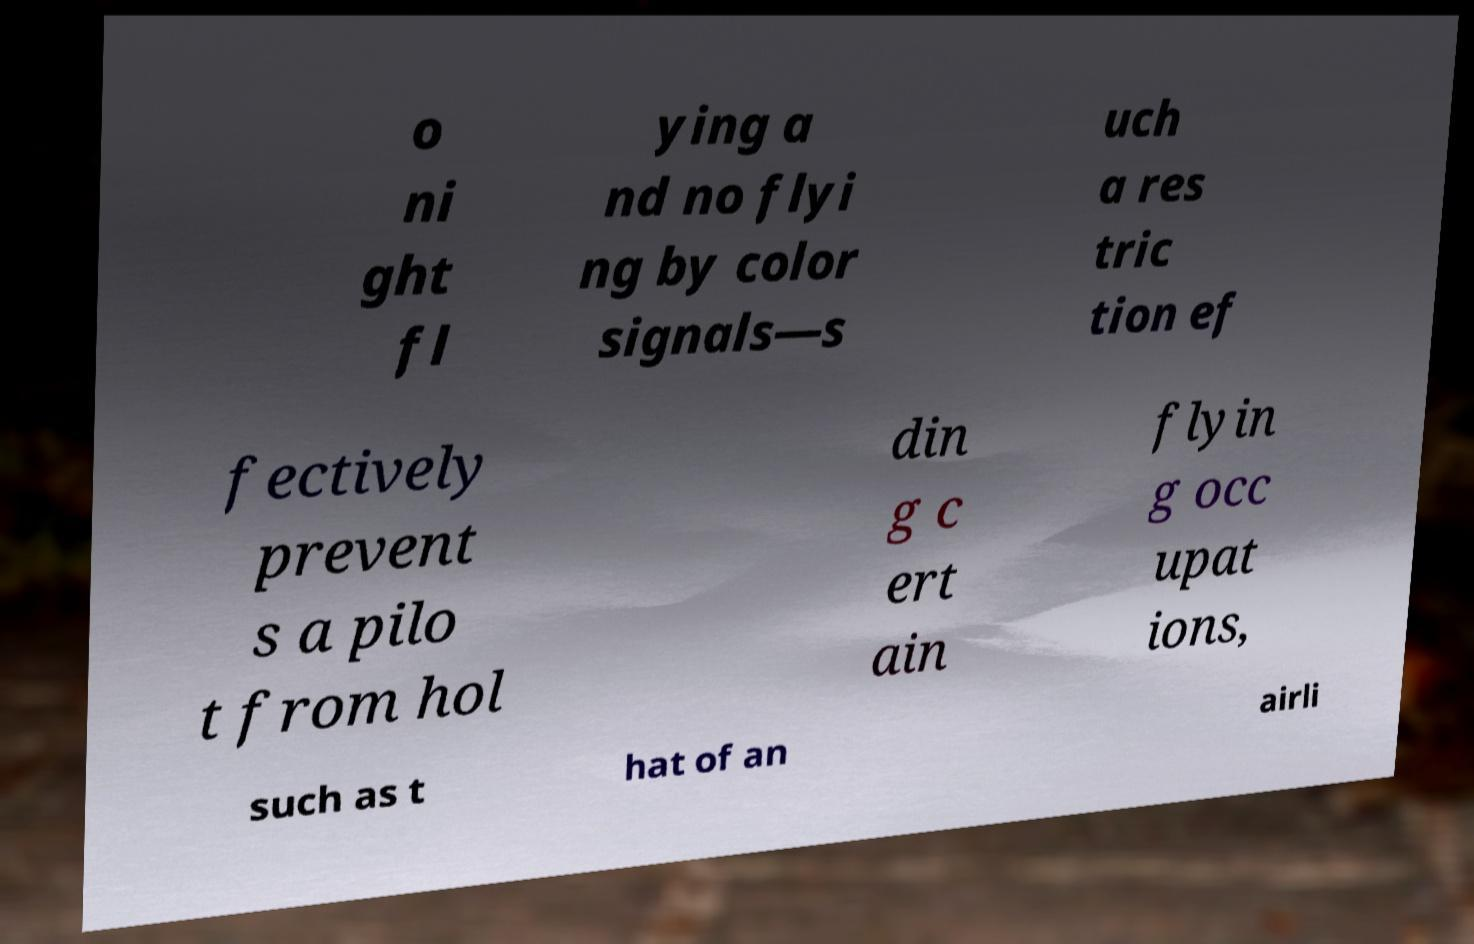Please read and relay the text visible in this image. What does it say? o ni ght fl ying a nd no flyi ng by color signals—s uch a res tric tion ef fectively prevent s a pilo t from hol din g c ert ain flyin g occ upat ions, such as t hat of an airli 